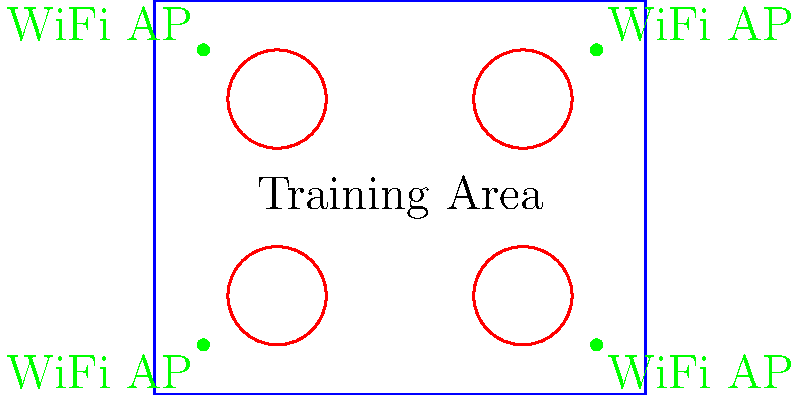Your martial arts school has a large training area (10m x 8m) with four separate practice zones. To ensure optimal Wi-Fi coverage for digital training aids and online streaming, you need to position Wi-Fi access points. Given the layout shown in the diagram, what is the minimum number of Wi-Fi access points needed to provide adequate coverage for the entire training area, assuming each access point has a range of approximately 5 meters? To determine the minimum number of Wi-Fi access points needed, we'll follow these steps:

1. Analyze the dimensions of the training area:
   The training area is 10m x 8m.

2. Consider the range of each Wi-Fi access point:
   Each access point has a range of approximately 5 meters.

3. Calculate the coverage area of a single access point:
   The coverage area is roughly circular, with a radius of 5 meters.
   Area = $\pi r^2 = \pi (5m)^2 \approx 78.5m^2$

4. Compare the coverage area to the total training area:
   Total training area = 10m x 8m = $80m^2$

5. Determine the number of access points needed:
   One access point can cover most of the training area, but due to potential signal interference from equipment and people, and to ensure coverage in corners, we need more than one.

6. Consider the layout and practice zones:
   To ensure all four practice zones have strong coverage, we need to position access points strategically.

7. Optimal placement:
   Place one access point in each corner of the training area. This setup provides overlapping coverage and ensures strong signal strength throughout the entire space, including all practice zones.

8. Count the number of access points:
   The optimal setup requires 4 access points, one in each corner.

Therefore, the minimum number of Wi-Fi access points needed to provide adequate coverage for the entire training area is 4.
Answer: 4 access points 